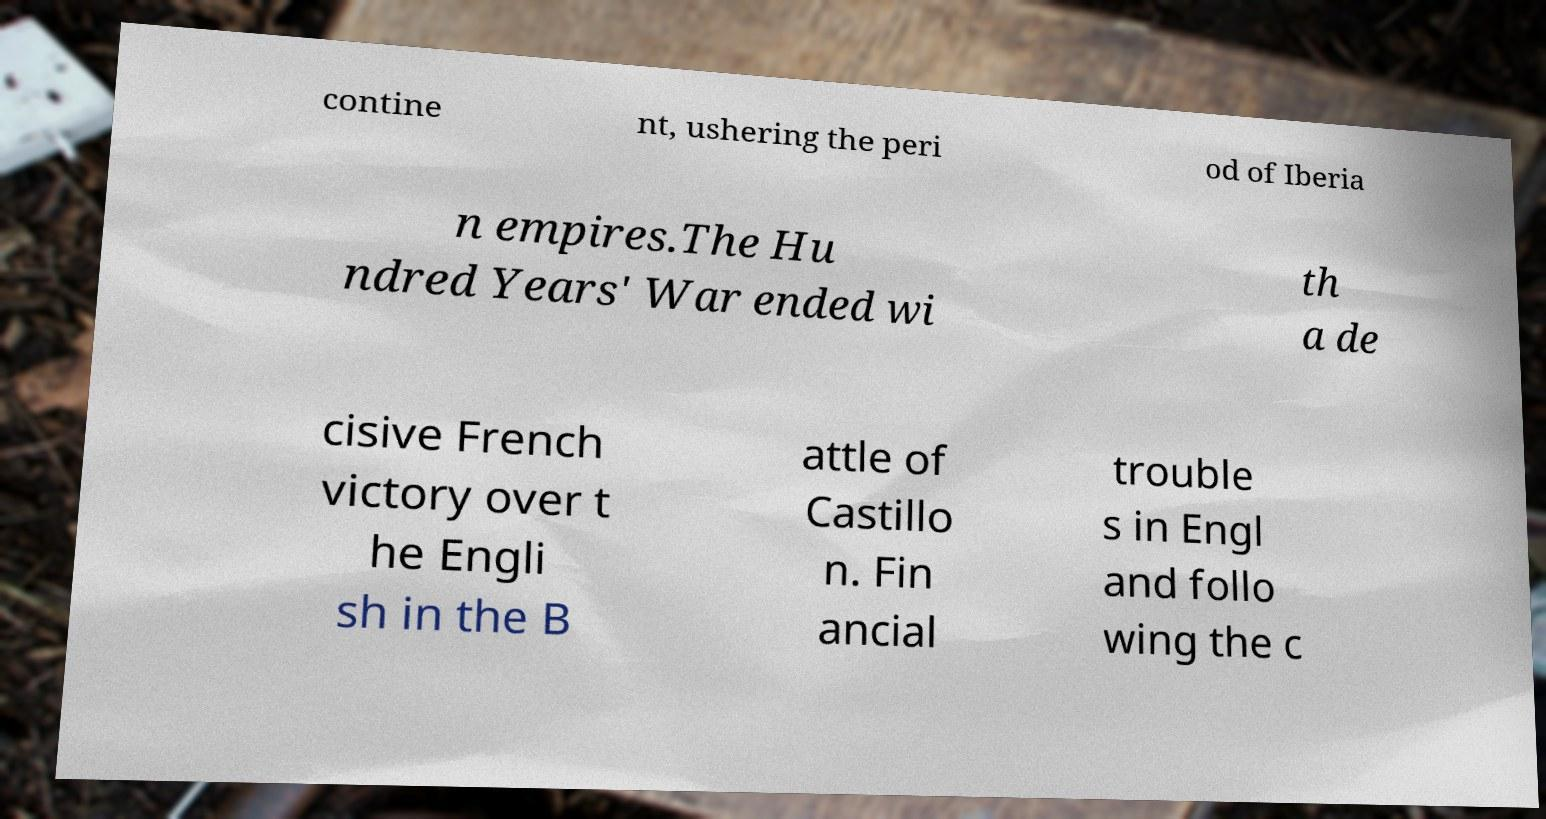Can you read and provide the text displayed in the image?This photo seems to have some interesting text. Can you extract and type it out for me? contine nt, ushering the peri od of Iberia n empires.The Hu ndred Years' War ended wi th a de cisive French victory over t he Engli sh in the B attle of Castillo n. Fin ancial trouble s in Engl and follo wing the c 